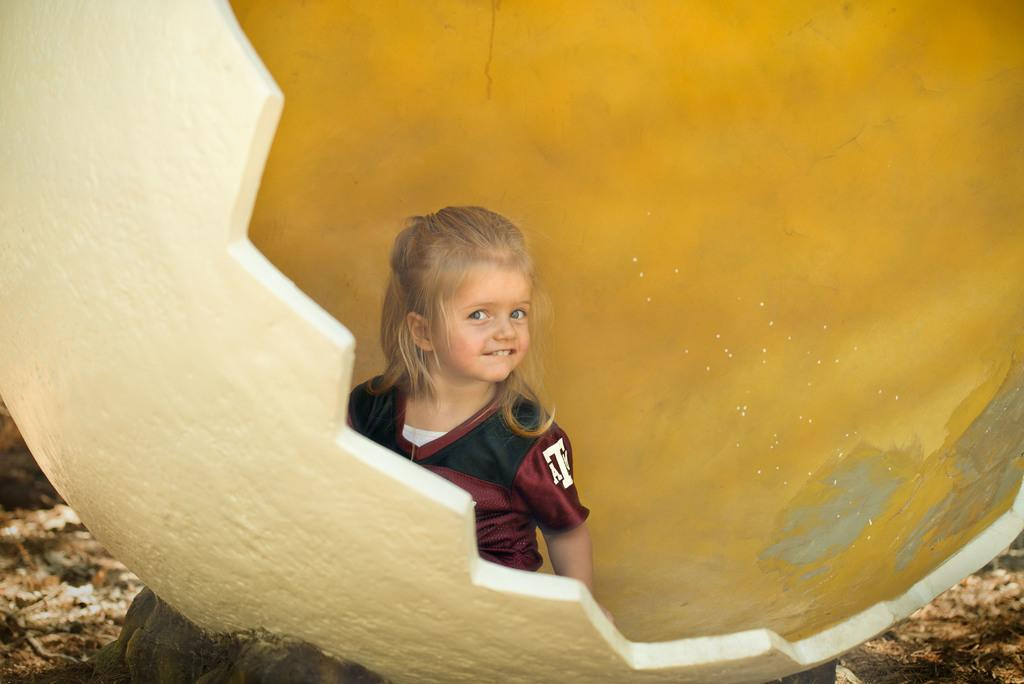Who is the main subject in the image? There is a girl in the center of the image. What can be seen in the background of the image? There is a globe and the ground visible in the background of the image. What type of sugar is being used to sweeten the basin in the image? There is no basin or sugar present in the image. 